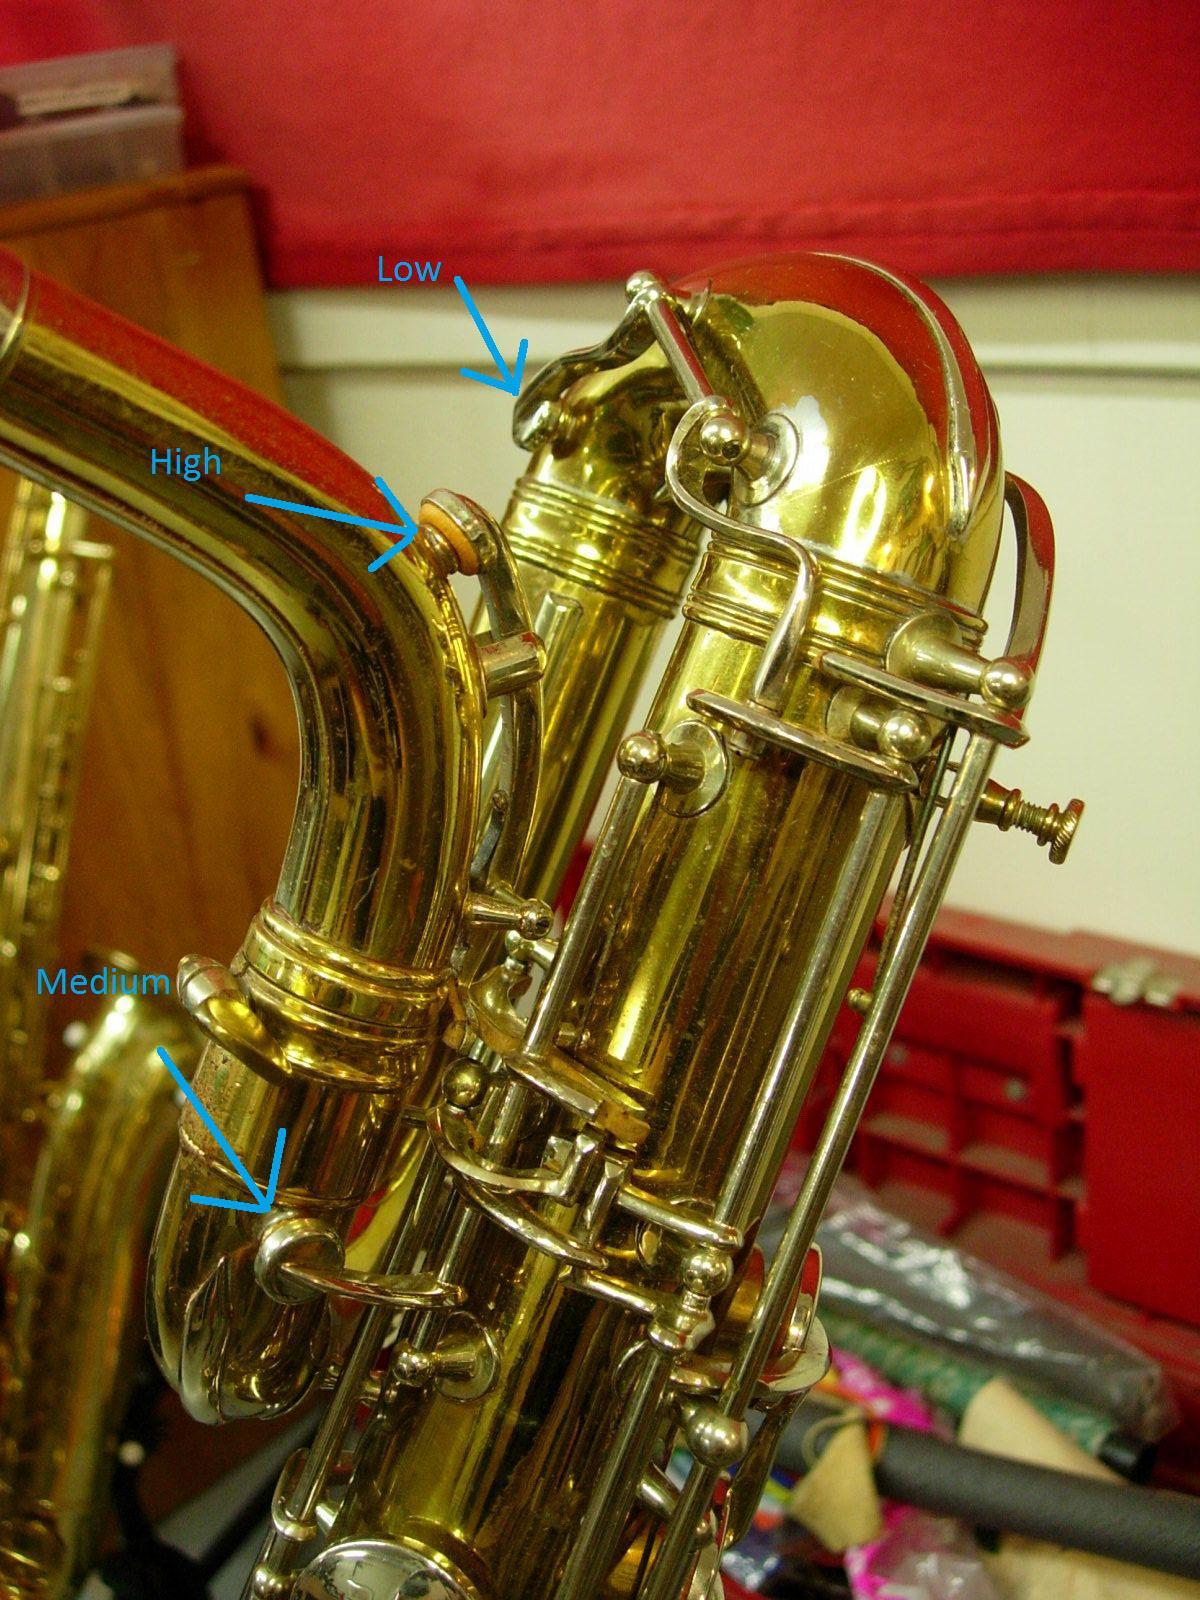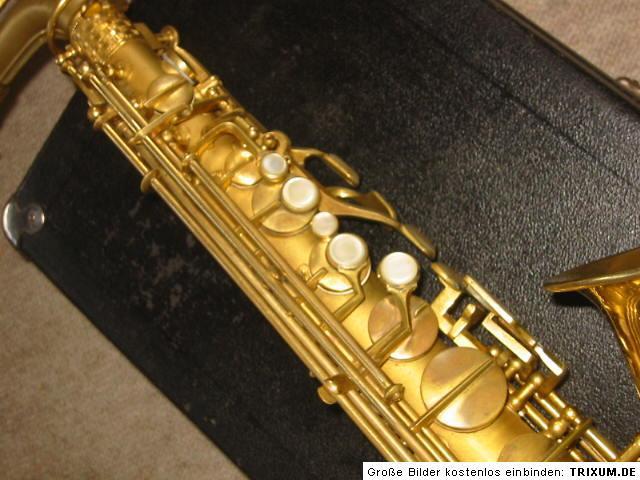The first image is the image on the left, the second image is the image on the right. Analyze the images presented: Is the assertion "A section of a brass-colored instrument containing button and lever shapes is displayed on a white background." valid? Answer yes or no. No. The first image is the image on the left, the second image is the image on the right. Considering the images on both sides, is "There are two instruments close up, with no real sign of the surrounding room." valid? Answer yes or no. No. 